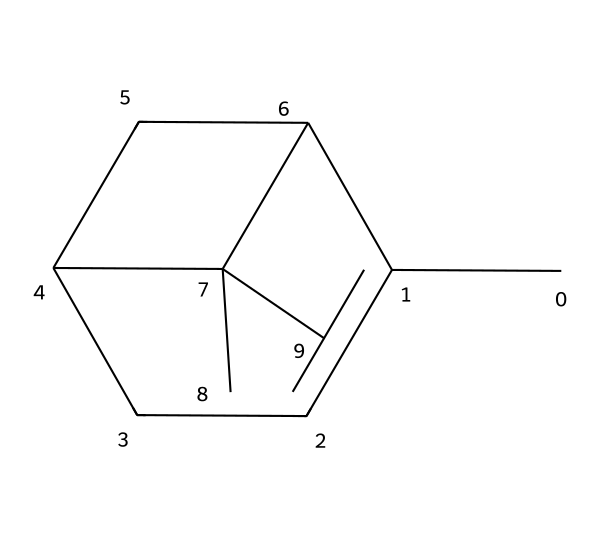What is the molecular formula of pinene? By analyzing the SMILES representation, each atom type can be counted. The structure contains 10 carbon (C) atoms and 16 hydrogen (H) atoms, leading to the molecular formula C10H16.
Answer: C10H16 How many rings are present in the pinene structure? Observing the structure based on the SMILES representation, there are two cycles formed by the carbon atoms. Counting these reveals a total of 2 rings in the compound.
Answer: 2 Which functional group is dominant in pinene? In the context of terpenes, a predominant feature is the presence of double bonds. Evaluating the SMILES, there are no explicit functional groups like alcohols or aldehydes; therefore, we can conclude that this compound is primarily a hydrocarbon with a dominant alkene character due to the presence of carbon-carbon double bonds.
Answer: alkene What type of compound is pinene? The analysis of the molecular structure shows that pinene is a terpene derived from natural sources, particularly from the essential oils of pine trees, confirming that it belongs to the category of terpenes.
Answer: terpene How many hydrogen atoms are there per carbon atom in pinene? The molecular formula C10H16 indicates there are 16 hydrogen atoms for 10 carbon atoms. To find the ratio, divide the number of hydrogen atoms by the number of carbon atoms: 16/10 = 1.6.
Answer: 1.6 